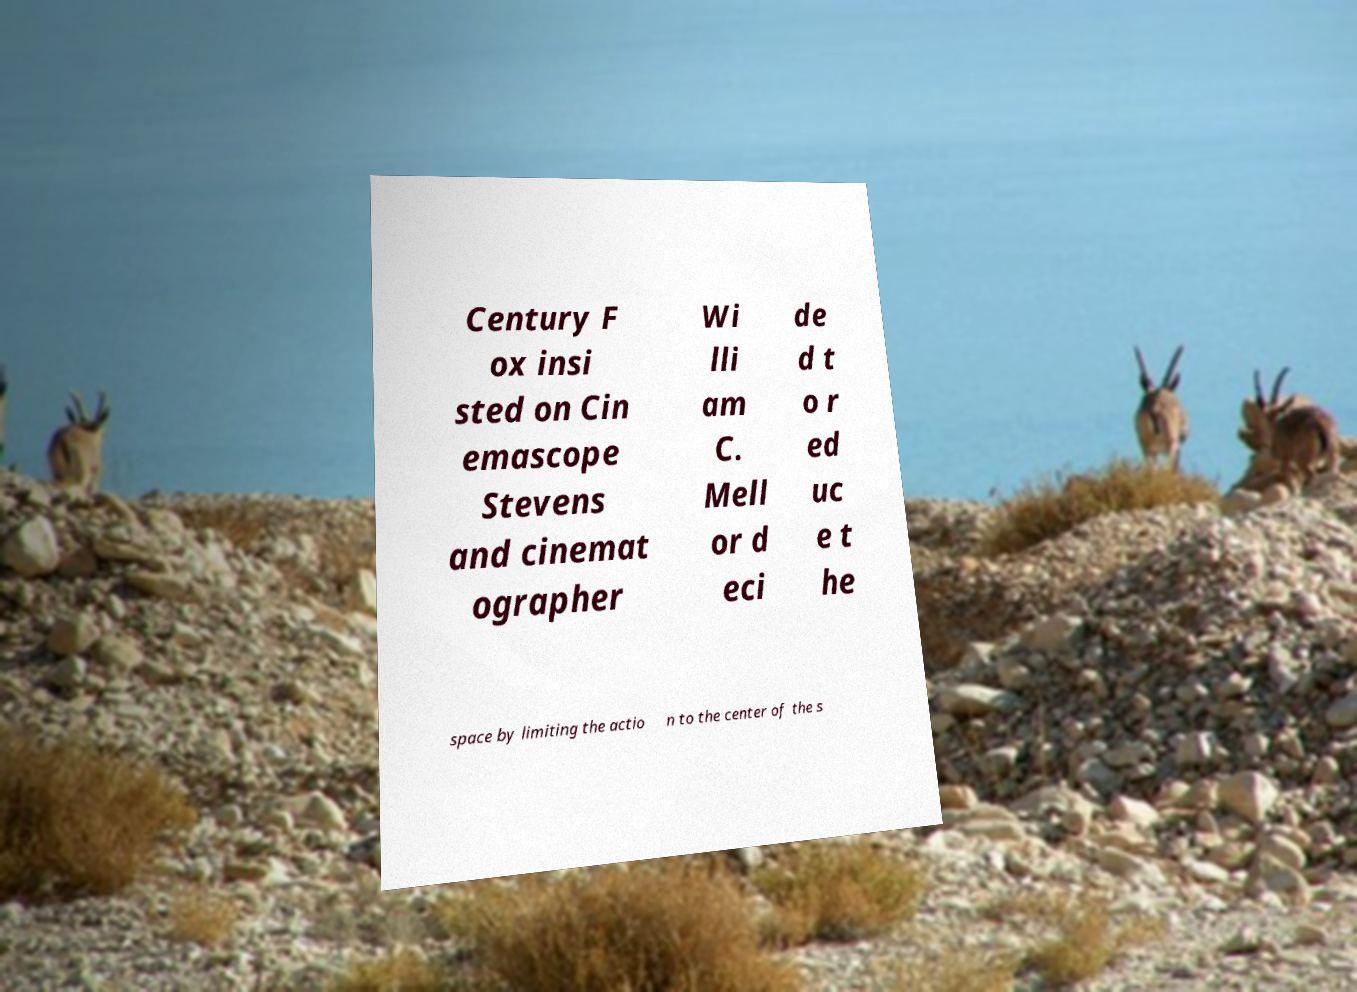What messages or text are displayed in this image? I need them in a readable, typed format. Century F ox insi sted on Cin emascope Stevens and cinemat ographer Wi lli am C. Mell or d eci de d t o r ed uc e t he space by limiting the actio n to the center of the s 